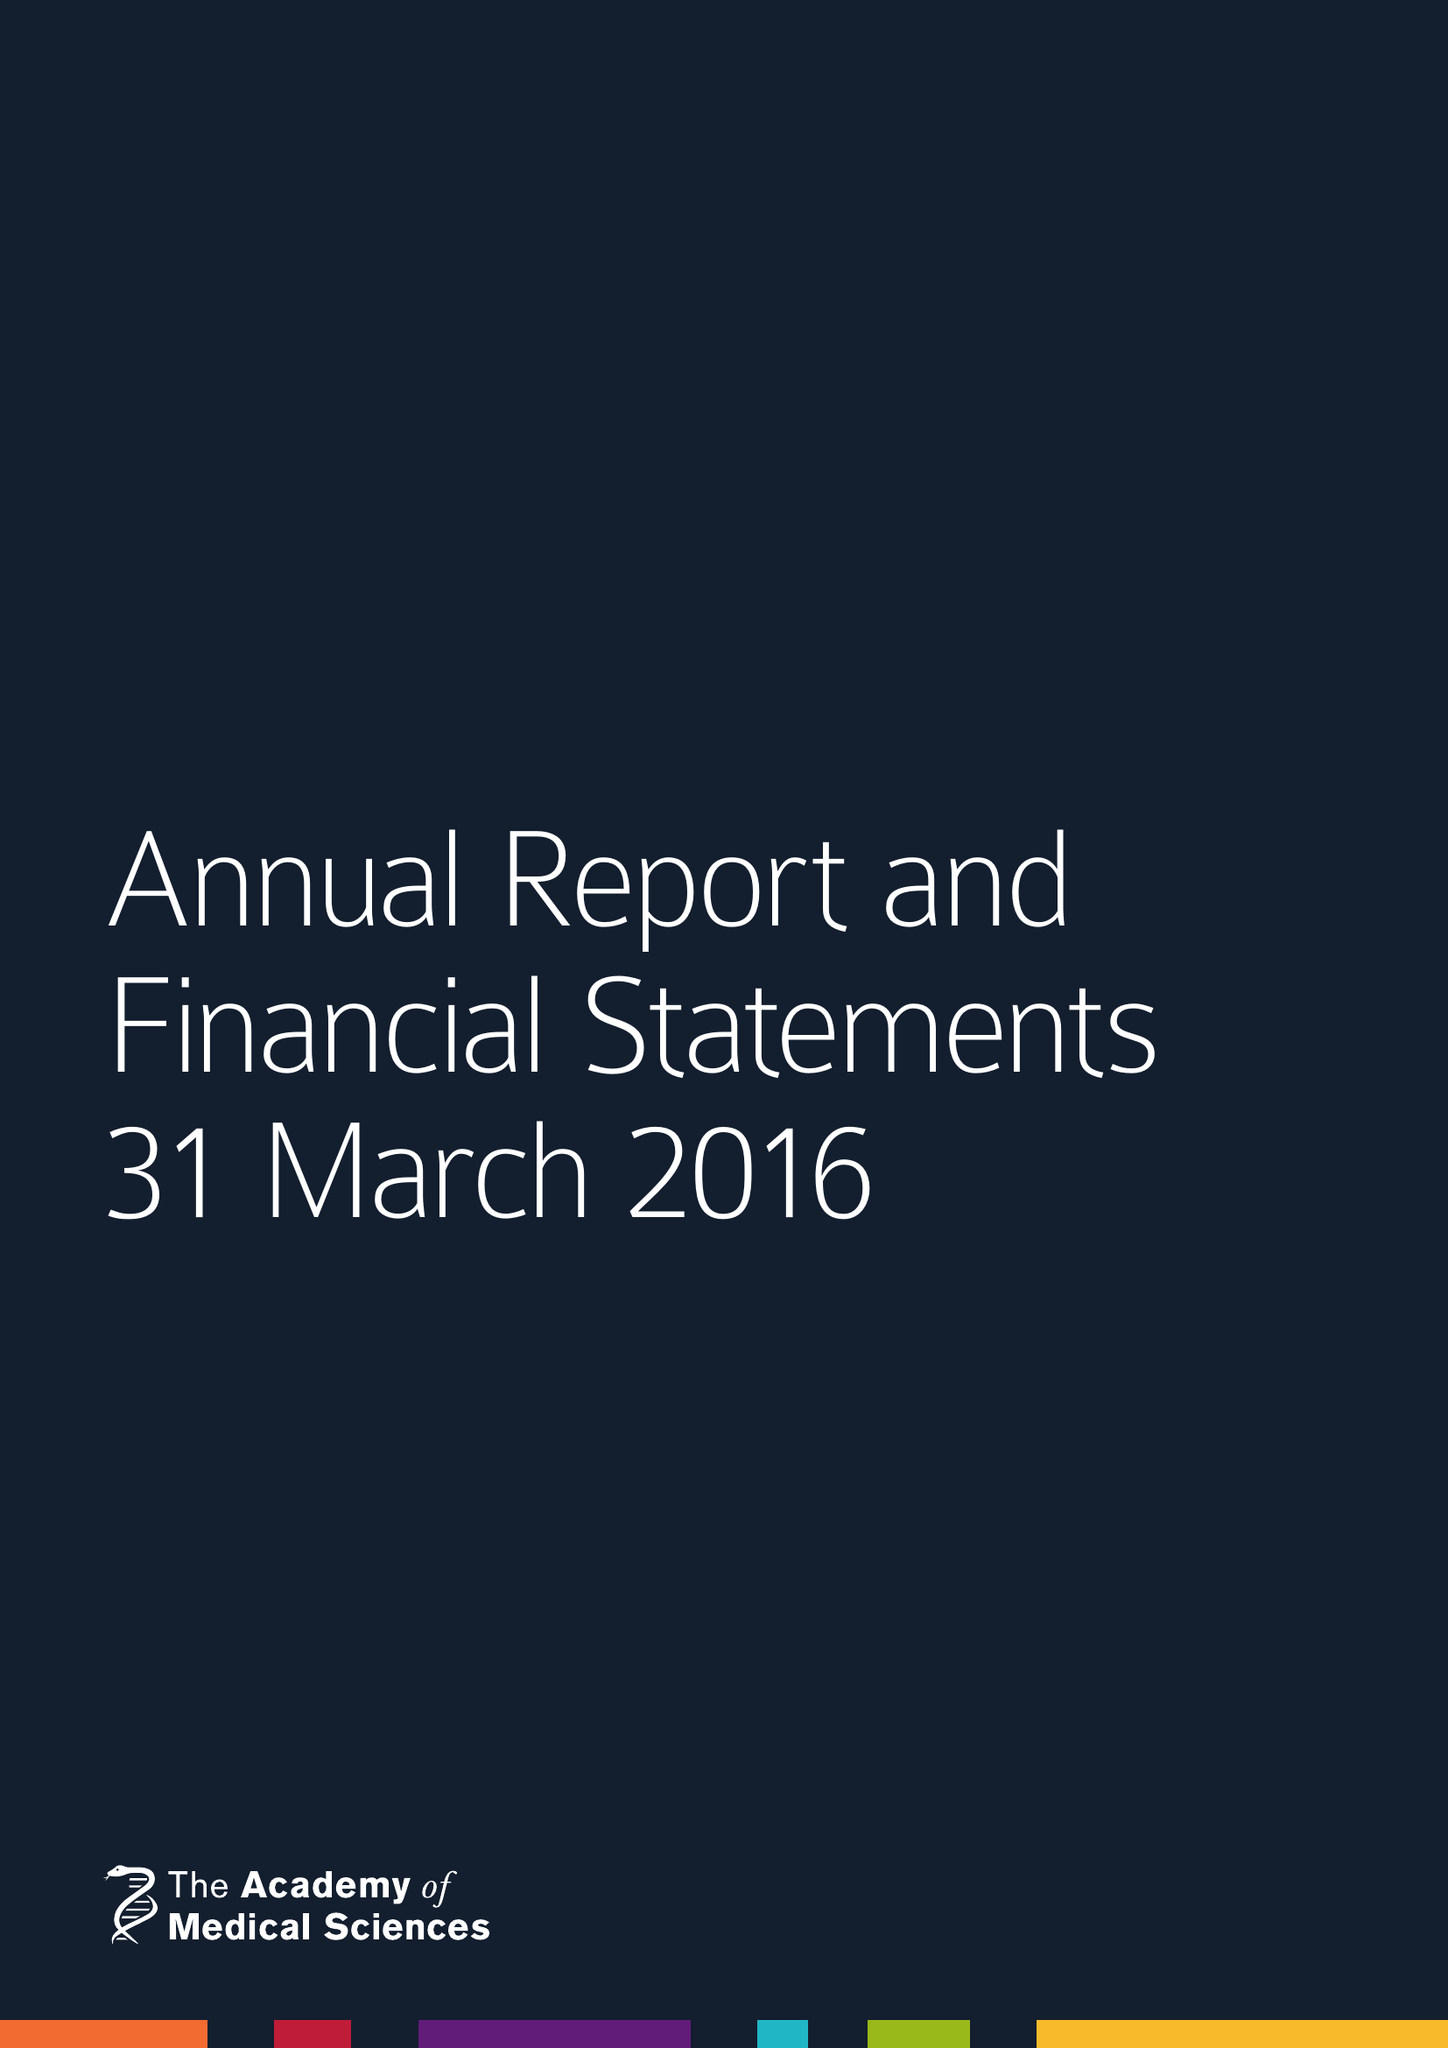What is the value for the income_annually_in_british_pounds?
Answer the question using a single word or phrase. 8110122.00 